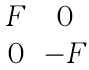<formula> <loc_0><loc_0><loc_500><loc_500>\begin{matrix} F & 0 \\ 0 & - F \\ \end{matrix}</formula> 